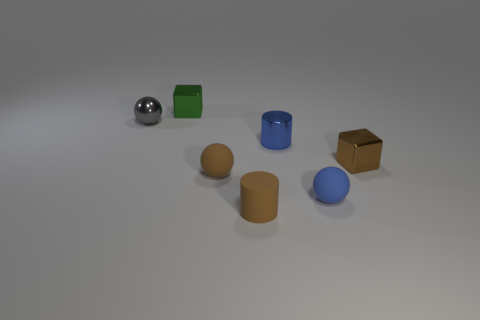How many shiny cubes are in front of the small blue metal object and behind the small metallic cylinder?
Your response must be concise. 0. The cube to the left of the shiny block that is right of the matte thing that is on the right side of the small blue metal object is what color?
Give a very brief answer. Green. How many cubes are in front of the object behind the tiny gray object?
Give a very brief answer. 1. How many other things are there of the same shape as the small blue shiny object?
Your answer should be very brief. 1. How many things are tiny matte objects or small shiny blocks to the left of the small blue sphere?
Offer a very short reply. 4. Is the number of metal spheres that are to the right of the tiny brown metallic object greater than the number of tiny gray metal things that are on the right side of the tiny brown cylinder?
Your response must be concise. No. What is the shape of the tiny blue object that is behind the small shiny object that is in front of the blue shiny object in front of the small green cube?
Keep it short and to the point. Cylinder. The metal thing right of the metal cylinder left of the small brown cube is what shape?
Provide a short and direct response. Cube. Are there any small balls made of the same material as the small brown cube?
Keep it short and to the point. Yes. There is a metallic object that is the same color as the rubber cylinder; what size is it?
Give a very brief answer. Small. 